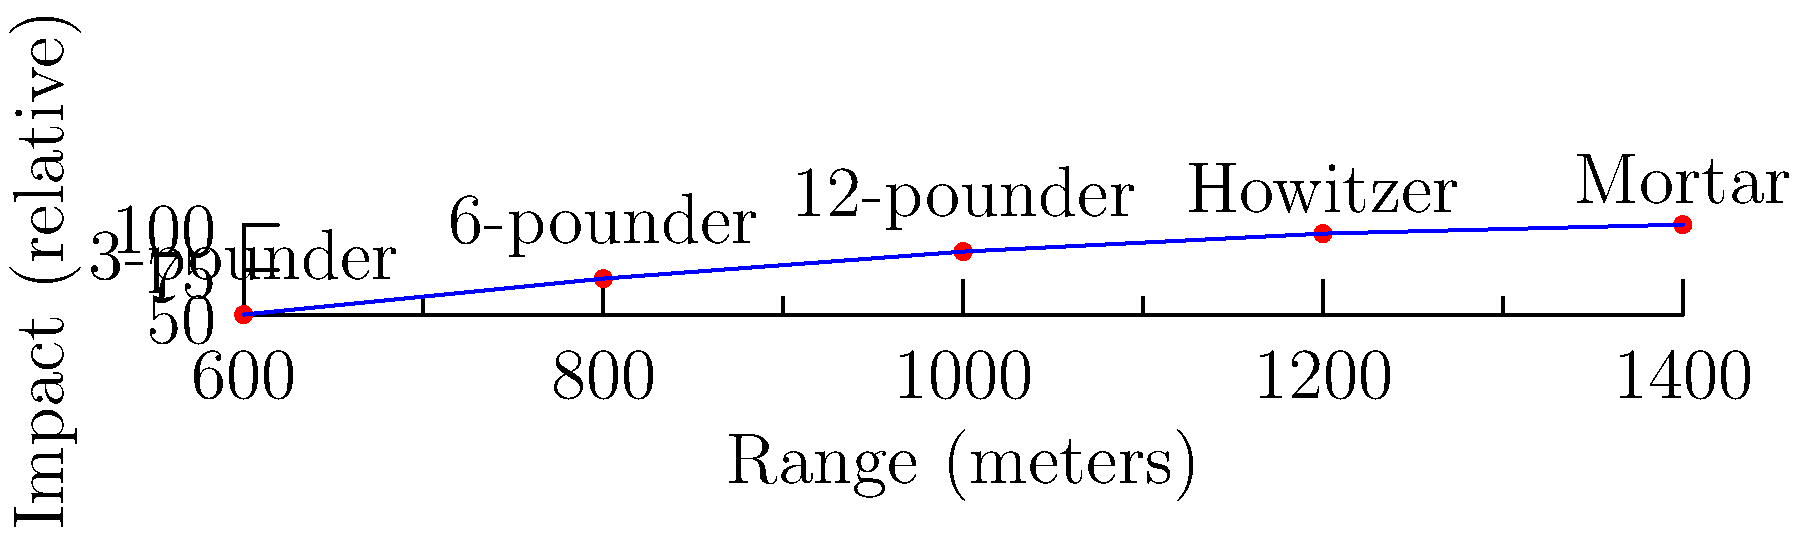Based on the chart comparing various artillery weapons used during the Napoleonic Wars, which weapon type demonstrates the highest combination of range and impact, and how might this have influenced battlefield tactics? To answer this question, we need to analyze the chart step-by-step:

1. The chart shows five types of artillery weapons used in the Napoleonic Wars: 3-pounder, 6-pounder, 12-pounder, Howitzer, and Mortar.

2. The x-axis represents the range in meters, while the y-axis shows the relative impact.

3. Examining the data points:
   - 3-pounder: Shortest range, lowest impact
   - 6-pounder: Slightly better range and impact than 3-pounder
   - 12-pounder: Mid-range weapon with good impact
   - Howitzer: Long-range weapon with high impact
   - Mortar: Longest range and highest impact

4. The Mortar clearly demonstrates the highest combination of range and impact.

5. Influence on battlefield tactics:
   - Mortars could be used to attack enemy positions from a safe distance
   - Their high impact made them effective against fortifications and concentrated troops
   - Commanders could use mortars to soften enemy defenses before infantry assaults
   - The long range allowed for more flexible positioning of artillery units
   - However, their indirect fire nature might have made them less accurate for hitting moving targets

This combination of long-range and high impact would have given commanders using mortars a significant tactical advantage in siege warfare and battles with fixed positions.
Answer: Mortar; enabled long-range, high-impact strikes, influencing siege tactics and defensive positioning. 